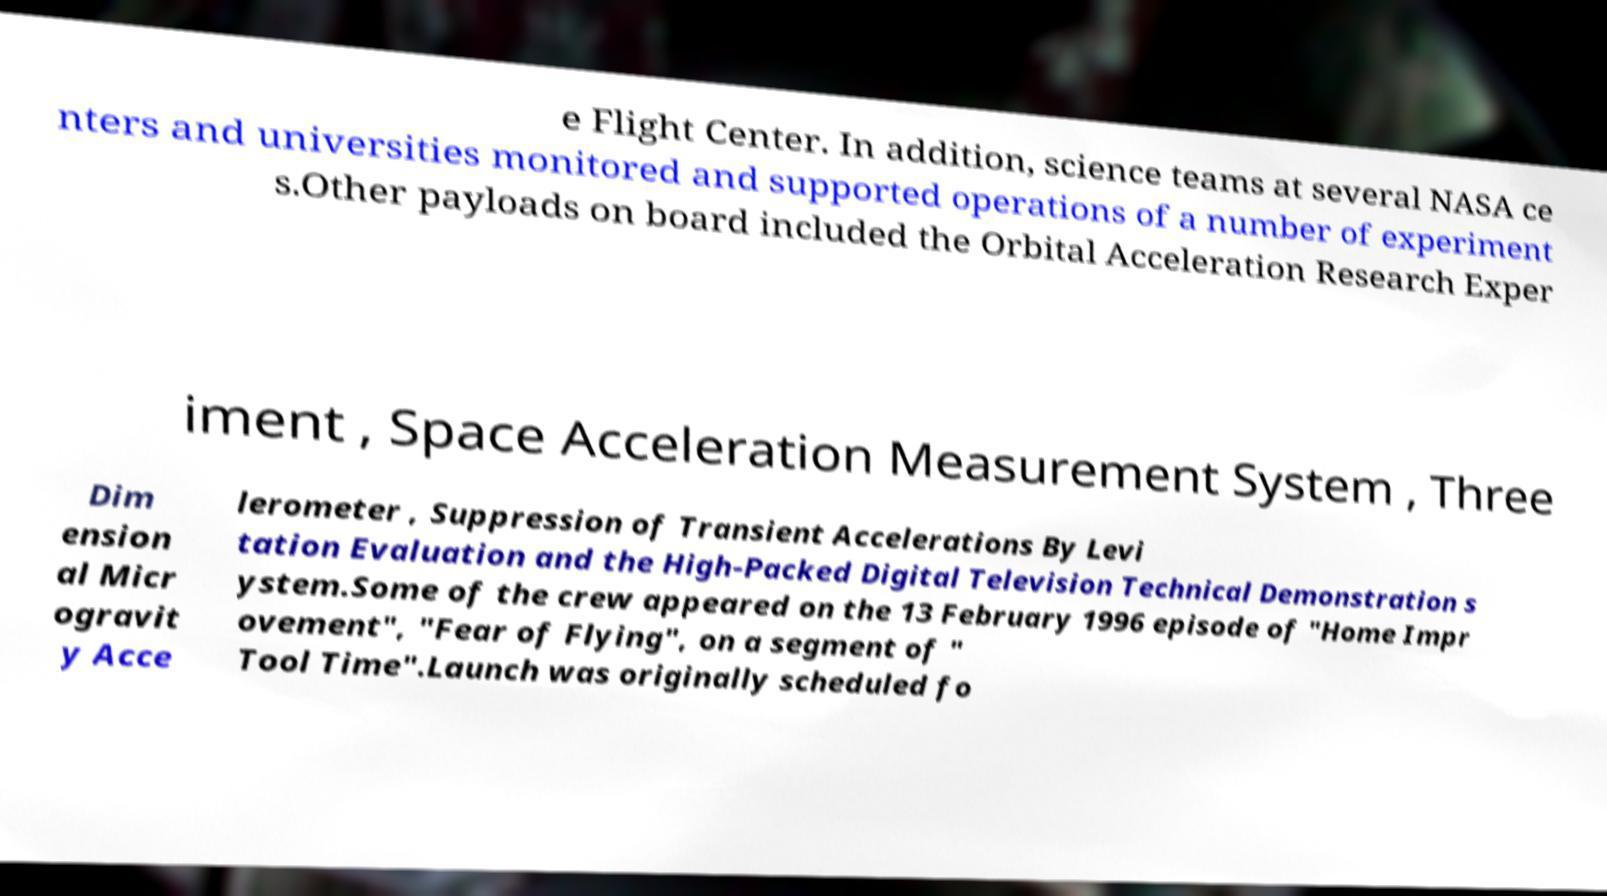Can you read and provide the text displayed in the image?This photo seems to have some interesting text. Can you extract and type it out for me? e Flight Center. In addition, science teams at several NASA ce nters and universities monitored and supported operations of a number of experiment s.Other payloads on board included the Orbital Acceleration Research Exper iment , Space Acceleration Measurement System , Three Dim ension al Micr ogravit y Acce lerometer , Suppression of Transient Accelerations By Levi tation Evaluation and the High-Packed Digital Television Technical Demonstration s ystem.Some of the crew appeared on the 13 February 1996 episode of "Home Impr ovement", "Fear of Flying", on a segment of " Tool Time".Launch was originally scheduled fo 